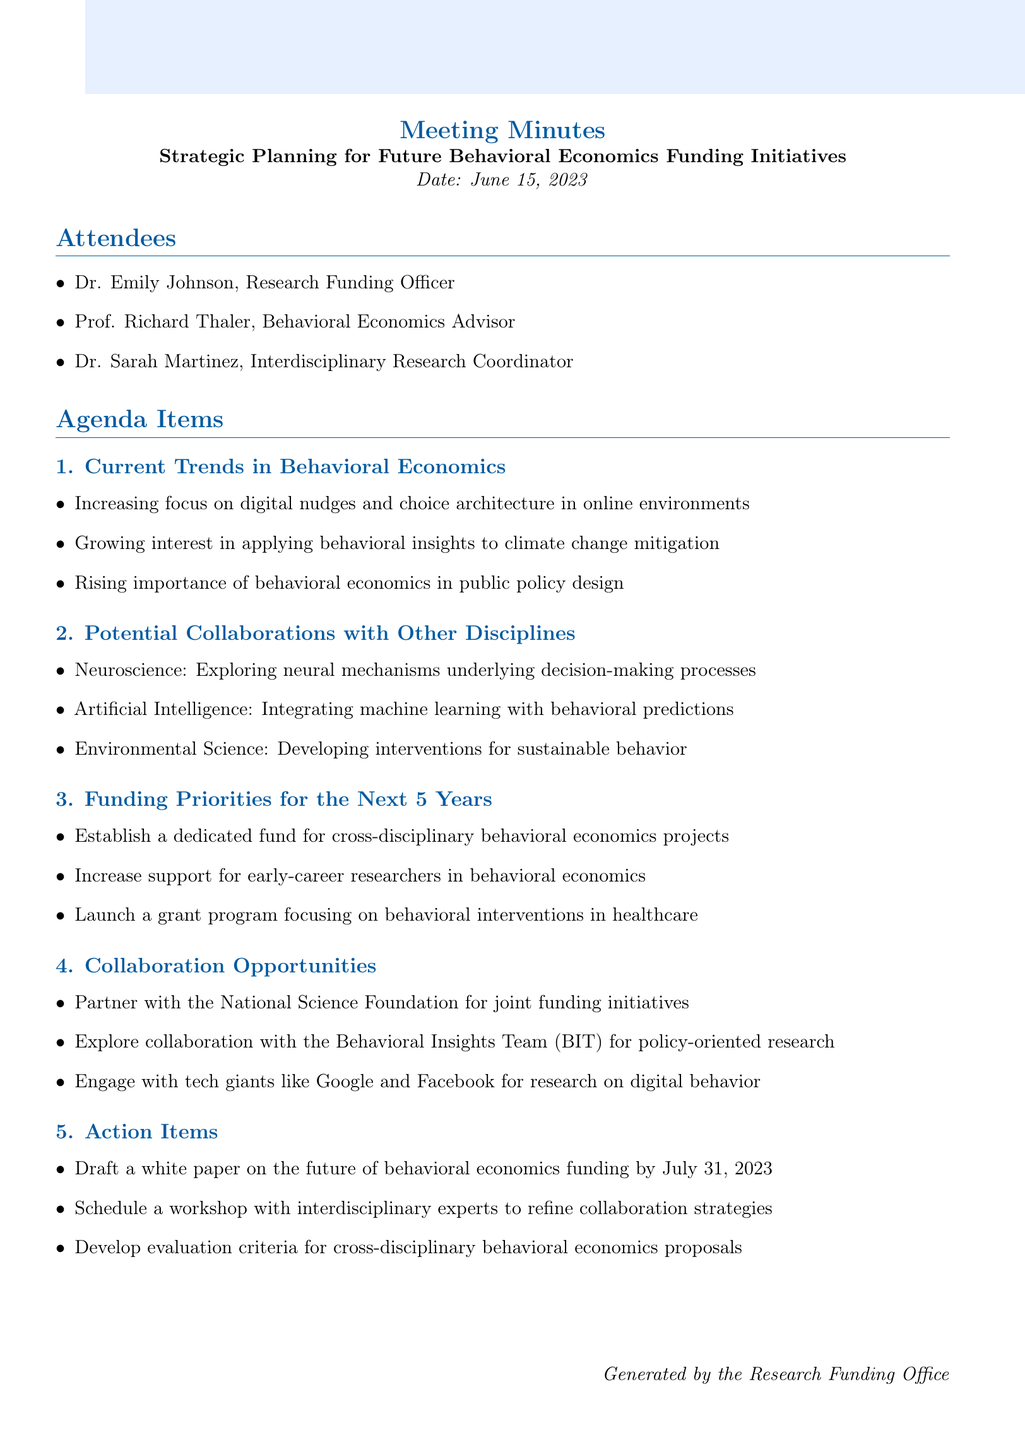What is the meeting title? The meeting title is explicitly mentioned at the beginning of the document as part of the introduction.
Answer: Strategic Planning for Future Behavioral Economics Funding Initiatives Who is the Behavioral Economics Advisor present at the meeting? The document lists attendees, including their titles and names, making it clear who is in attendance.
Answer: Prof. Richard Thaler What date was the meeting held? The date of the meeting is provided in the introduction section of the document.
Answer: June 15, 2023 What is one of the current trends in behavioral economics discussed? Several key points about current trends are listed in the agenda item section, highlighting various trends.
Answer: Increasing focus on digital nudges and choice architecture in online environments Which discipline is suggested for collaboration to explore decision-making processes? The agenda on potential collaborations explicitly lists disciplines and their focus areas.
Answer: Neuroscience What are the funding priorities for the next five years? The priorities are outlined in the corresponding section, summarizing the main focus areas for future funding.
Answer: Establish a dedicated fund for cross-disciplinary behavioral economics projects What is the first action item mentioned in the document? Details of action items are listed under the action items section, showing tasks that need to be completed.
Answer: Draft a white paper on the future of behavioral economics funding by July 31, 2023 How many attendees were present at the meeting? The number of individuals listed in the attendees section provides a clear count.
Answer: Three What organization is suggested for a partnership regarding joint funding initiatives? The document includes collaboration opportunities, specifying potential partners for future funding initiatives.
Answer: National Science Foundation 